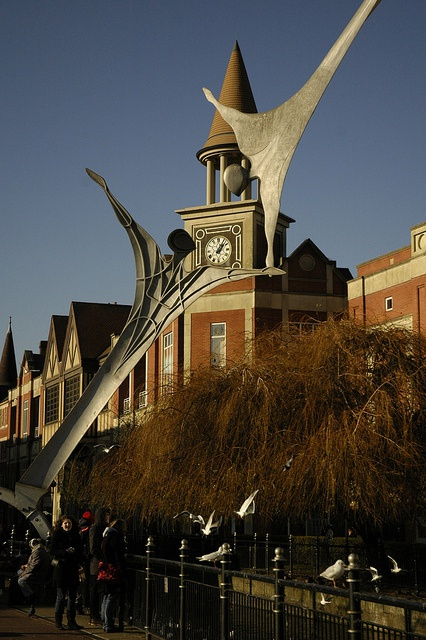Describe the objects in this image and their specific colors. I can see people in darkblue, black, maroon, and gray tones, people in darkblue, black, gray, and maroon tones, people in darkblue, black, maroon, and brown tones, people in darkblue, black, and gray tones, and people in darkblue, black, and maroon tones in this image. 